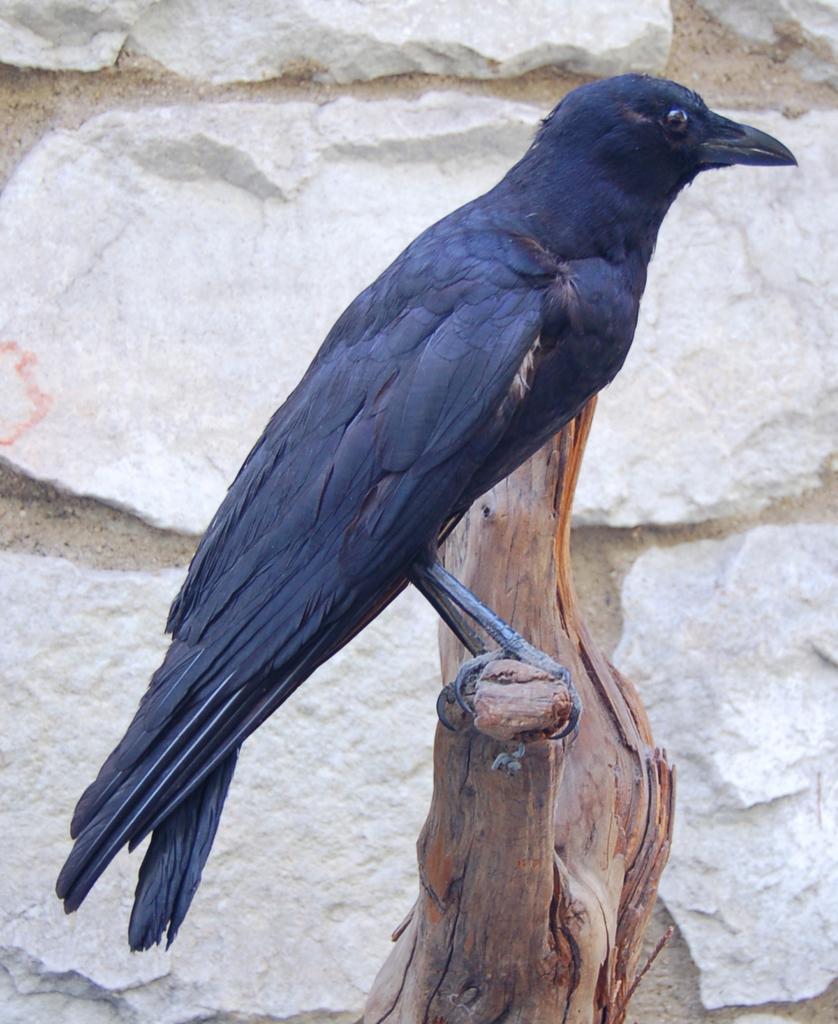Could you give a brief overview of what you see in this image? In this image on a wood. There is a crow. In the background there is stone wall. 